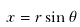<formula> <loc_0><loc_0><loc_500><loc_500>x = r \sin \theta</formula> 